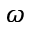<formula> <loc_0><loc_0><loc_500><loc_500>\omega</formula> 